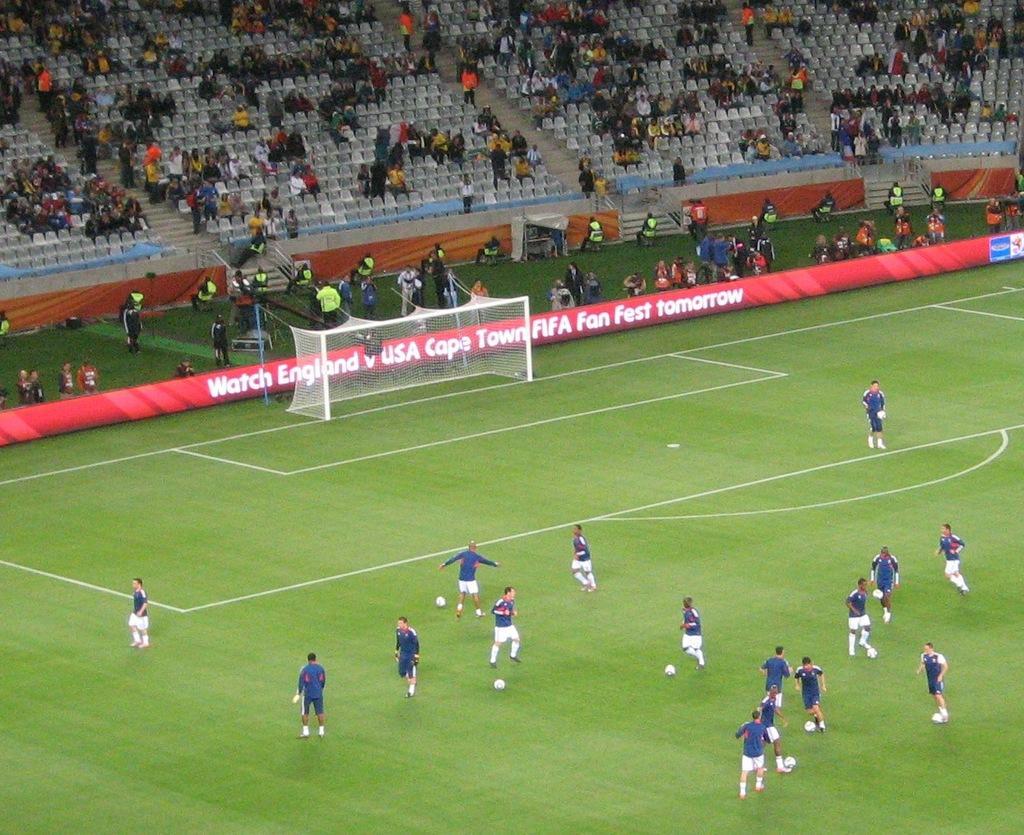In one or two sentences, can you explain what this image depicts? The image is taken in a football stadium. In the foreground of the picture there are people seen practicing the game. In the center of the picture there are banners, people, cameras goal post and other objects. At the top there are people and chairs. 